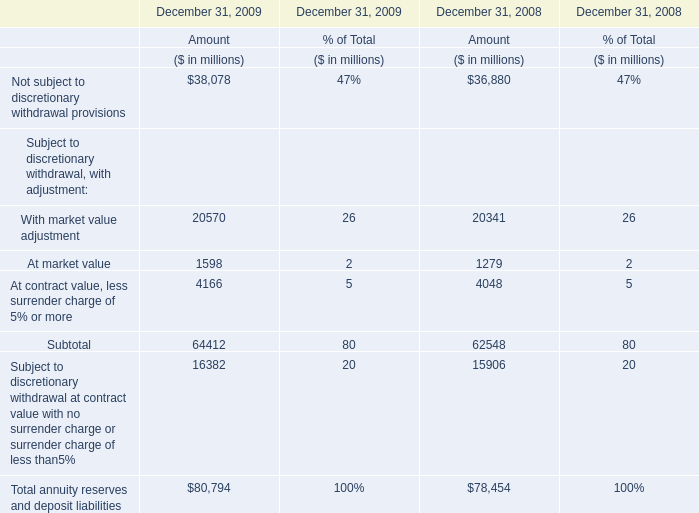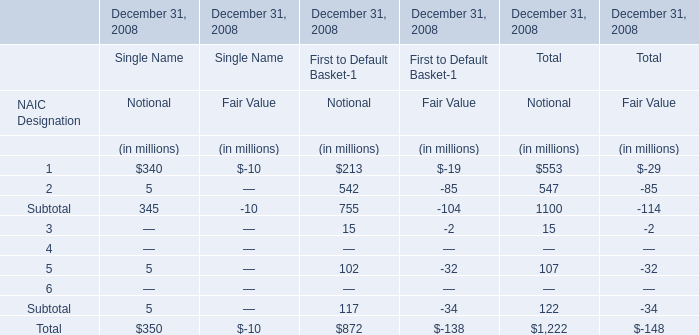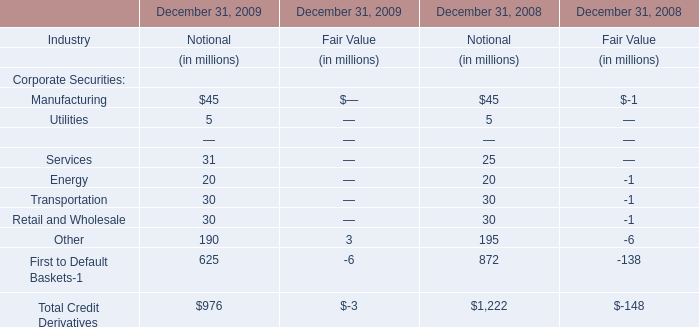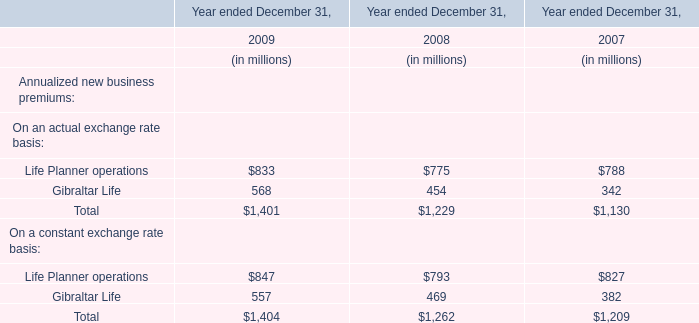What's the total amount of the Services of Corporate Securities for Notional in the years where Manufacturing of Corporate Securities greater than 0 for Notional? (in million) 
Computations: (31 + 25)
Answer: 56.0. 